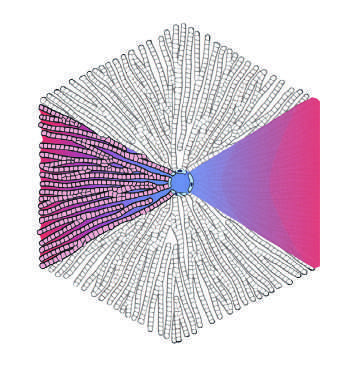re areas of chalky necrosis at the periphery?
Answer the question using a single word or phrase. No 